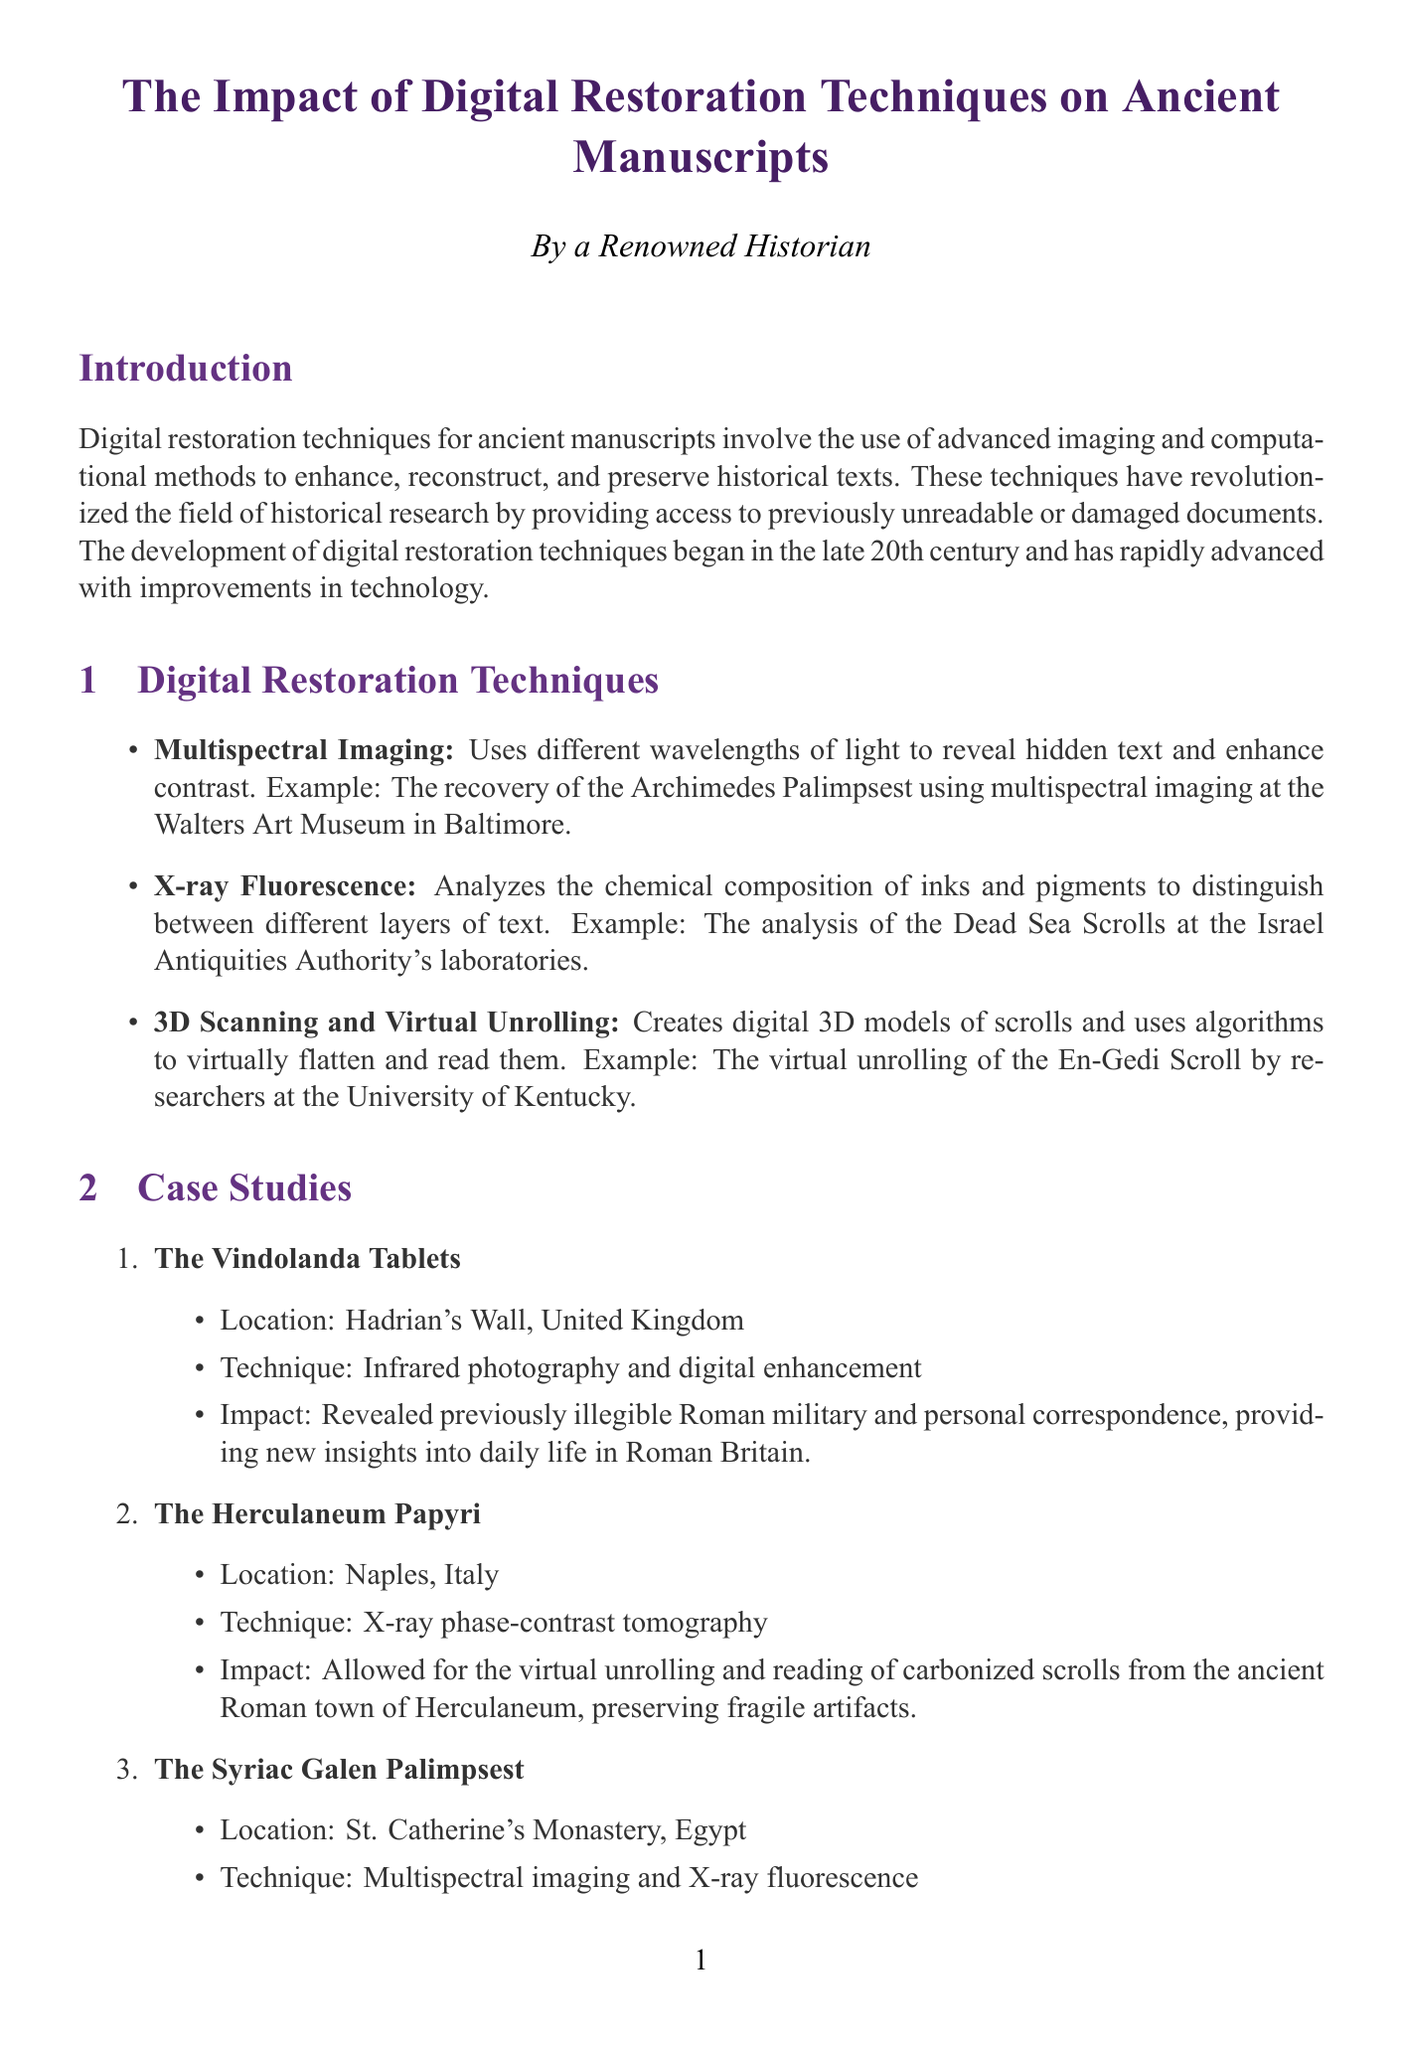What are digital restoration techniques? The document defines digital restoration techniques as the use of advanced imaging and computational methods to enhance, reconstruct, and preserve historical texts.
Answer: Advanced imaging and computational methods What technique was used on the En-Gedi Scroll? The document states that the technique used for the En-Gedi Scroll was 3D scanning and virtual unrolling.
Answer: 3D scanning and virtual unrolling Which manuscript's digital reconstruction is debated? The document highlights the debate surrounding the digital reconstruction of the Beowulf manuscript at the British Library.
Answer: Beowulf manuscript What significant finding resulted from the Syriac Galen Palimpsest? The document mentions that the restoration uncovered a previously unknown Syriac translation of Galen's medical treatises.
Answer: A previously unknown Syriac translation of Galen's medical treatises What kind of collaboration is prominent in digital restoration projects? The document states that digital restoration projects often involve collaboration between historians, conservators, and computer scientists.
Answer: Collaboration between historians, conservators, and computer scientists What ethical issue pertains to ownership of restored manuscripts? The document raises the issue of access and ownership regarding who owns and controls access to restored manuscripts.
Answer: Access and ownership How has digital restoration affected historical beliefs? The document indicates that digital restoration has led to the revision of established theories in history.
Answer: Revision of established theories When did the development of digital restoration techniques begin? The document mentions that the development of digital restoration techniques began in the late 20th century.
Answer: Late 20th century What future advancement is mentioned for digital restoration? The document notes the development of AI-powered restoration algorithms as a future advancement.
Answer: AI-powered restoration algorithms 